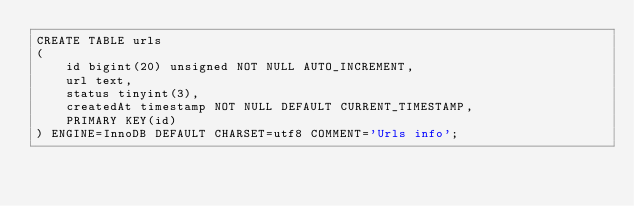Convert code to text. <code><loc_0><loc_0><loc_500><loc_500><_SQL_>CREATE TABLE urls
(
    id bigint(20) unsigned NOT NULL AUTO_INCREMENT,
    url text,
    status tinyint(3),
    createdAt timestamp NOT NULL DEFAULT CURRENT_TIMESTAMP,
    PRIMARY KEY(id)
) ENGINE=InnoDB DEFAULT CHARSET=utf8 COMMENT='Urls info';


</code> 